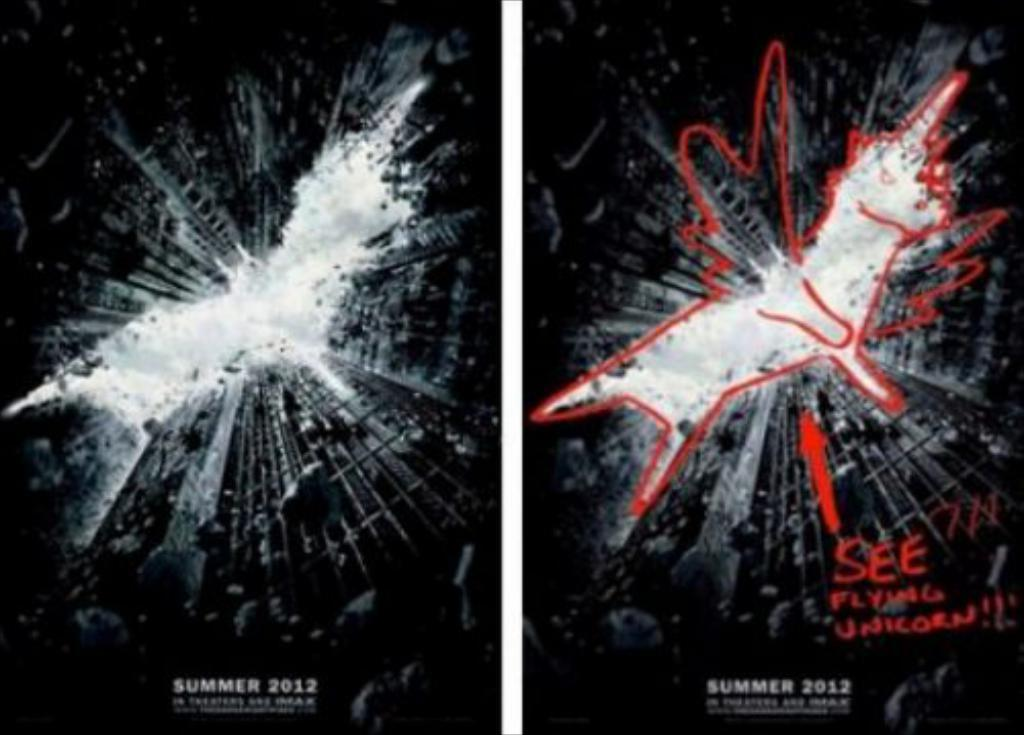<image>
Write a terse but informative summary of the picture. a film promotonal poster called see with a flying unicorn 